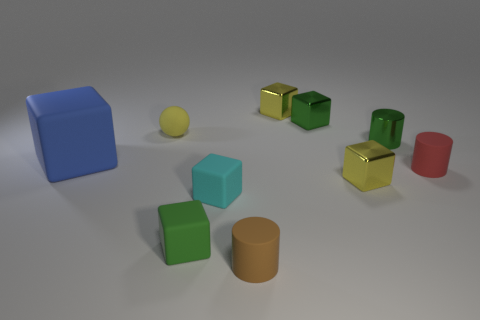Subtract 1 cubes. How many cubes are left? 5 Subtract all yellow blocks. How many blocks are left? 4 Subtract all blue cubes. How many cubes are left? 5 Subtract all red blocks. Subtract all red cylinders. How many blocks are left? 6 Subtract all balls. How many objects are left? 9 Add 5 metal objects. How many metal objects exist? 9 Subtract 0 brown cubes. How many objects are left? 10 Subtract all big objects. Subtract all cylinders. How many objects are left? 6 Add 6 brown rubber objects. How many brown rubber objects are left? 7 